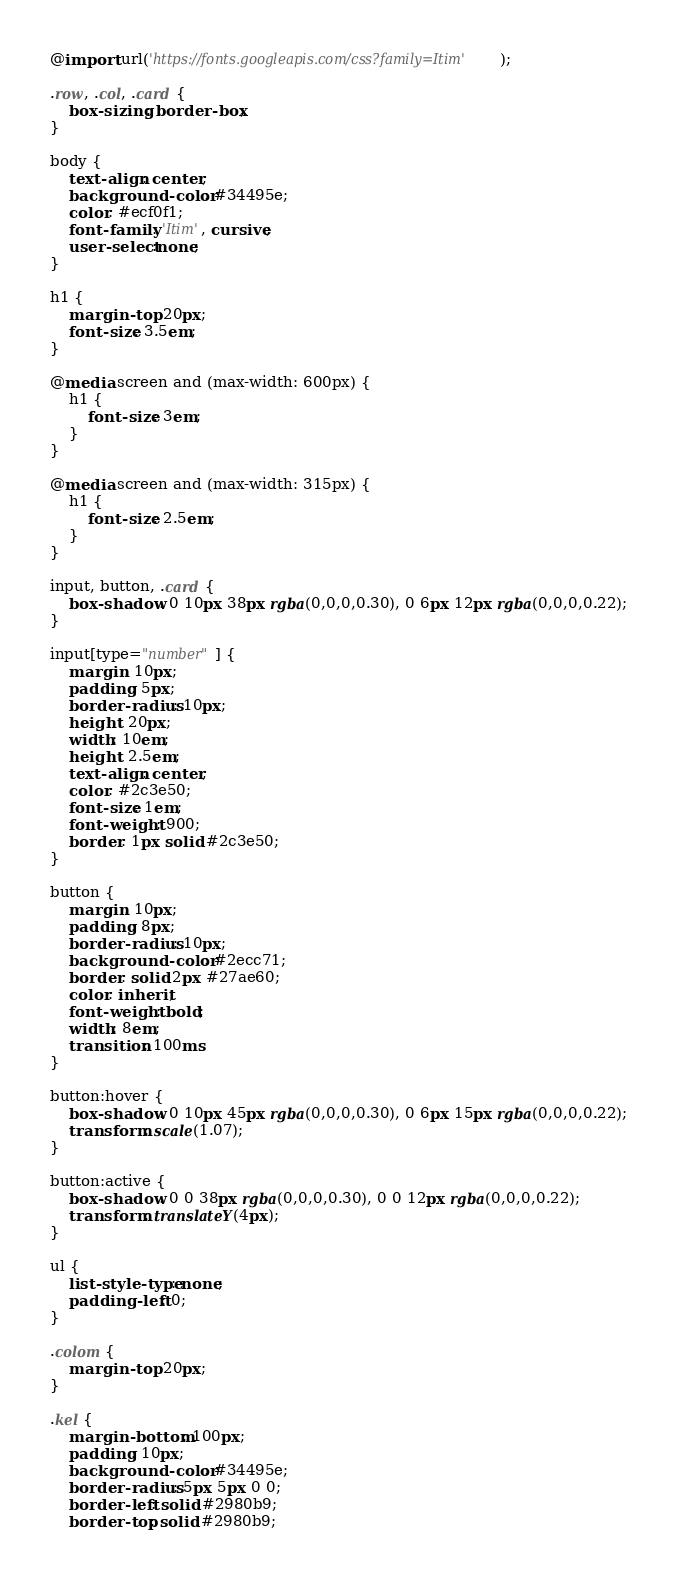Convert code to text. <code><loc_0><loc_0><loc_500><loc_500><_CSS_>@import url('https://fonts.googleapis.com/css?family=Itim');

.row, .col, .card {
    box-sizing: border-box;
}

body {
    text-align: center;
    background-color: #34495e;
    color: #ecf0f1;
    font-family: 'Itim', cursive;
    user-select:none;
}

h1 {
    margin-top: 20px;
    font-size: 3.5em;
}

@media screen and (max-width: 600px) {
    h1 {
        font-size: 3em;
    }
}

@media screen and (max-width: 315px) {
    h1 {
        font-size: 2.5em;
    }
}

input, button, .card {
    box-shadow: 0 10px 38px rgba(0,0,0,0.30), 0 6px 12px rgba(0,0,0,0.22);
}

input[type="number"] {
    margin: 10px;
    padding: 5px;
    border-radius: 10px;
    height: 20px;
    width: 10em;
    height: 2.5em;
    text-align: center;
    color: #2c3e50;
    font-size: 1em;
    font-weight: 900;
    border: 1px solid #2c3e50;
}

button {
    margin: 10px;
    padding: 8px;
    border-radius: 10px;
    background-color: #2ecc71;
    border: solid 2px #27ae60;
    color: inherit;
    font-weight: bold;
    width: 8em;
    transition: 100ms 
}

button:hover {
    box-shadow: 0 10px 45px rgba(0,0,0,0.30), 0 6px 15px rgba(0,0,0,0.22);
    transform: scale(1.07);
}

button:active {
    box-shadow: 0 0 38px rgba(0,0,0,0.30), 0 0 12px rgba(0,0,0,0.22);
    transform: translateY(4px);
}

ul {
    list-style-type: none;
    padding-left: 0;
}

.colom {
    margin-top: 20px;
}

.kel {
    margin-bottom: 100px;
    padding: 10px;
    background-color: #34495e;
    border-radius: 5px 5px 0 0;
    border-left: solid #2980b9;
    border-top: solid #2980b9;</code> 